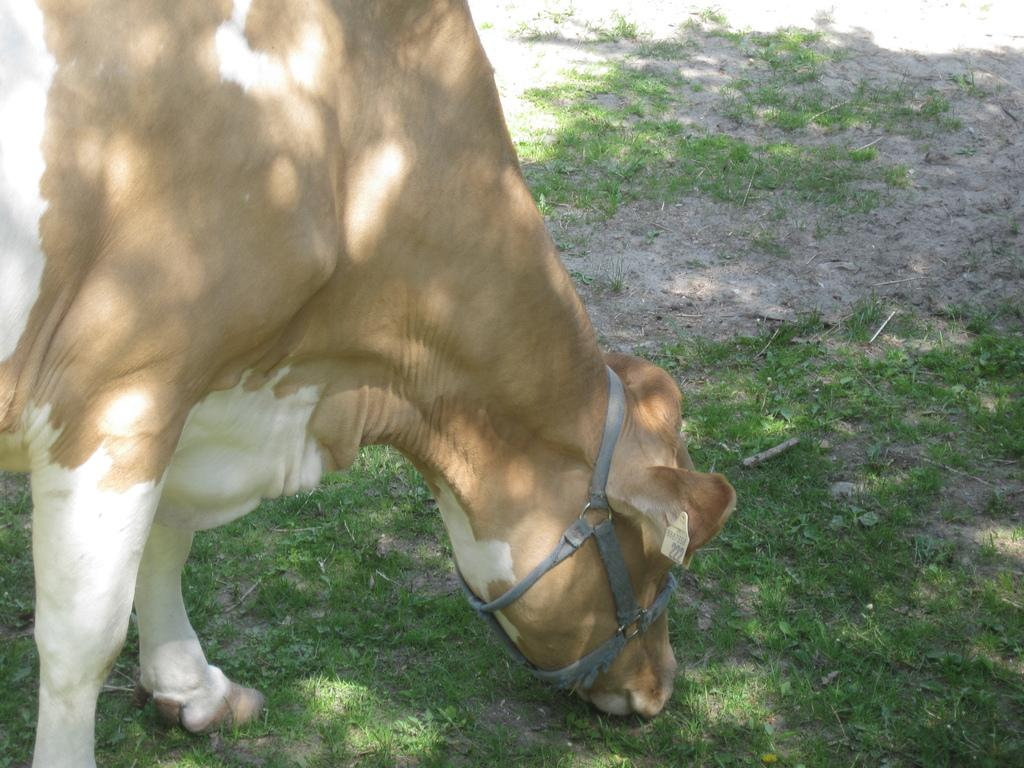What animal is the main subject of the picture? There is a cow in the picture. Can you describe the cow's appearance? The cow has a brown and white color. What is the cow doing in the picture? The cow is eating grass from the ground. What type of hydrant can be seen in the picture? There is no hydrant present in the picture; it features a cow eating grass. Who is the owner of the cow in the picture? There is no information about the cow's owner in the picture. 